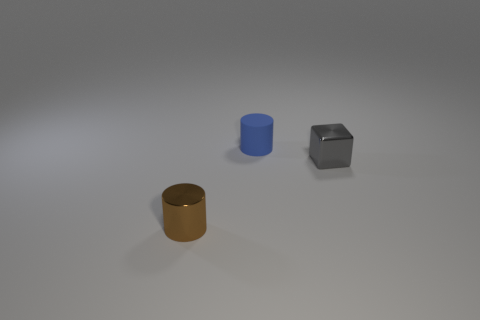Add 1 tiny gray balls. How many objects exist? 4 Subtract all blocks. How many objects are left? 2 Add 2 small blue rubber objects. How many small blue rubber objects exist? 3 Subtract 0 green balls. How many objects are left? 3 Subtract all brown objects. Subtract all tiny metallic cubes. How many objects are left? 1 Add 1 brown shiny things. How many brown shiny things are left? 2 